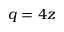<formula> <loc_0><loc_0><loc_500><loc_500>q = 4 z</formula> 